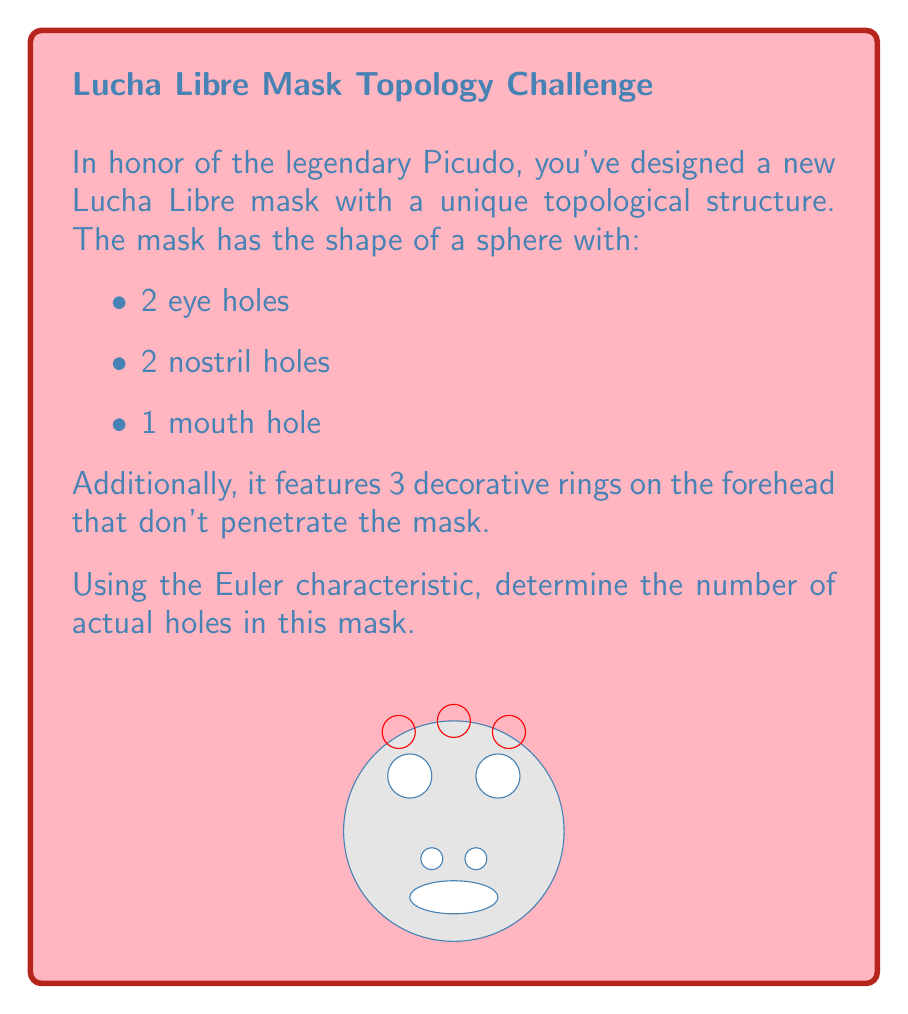Teach me how to tackle this problem. To solve this problem, we'll use the Euler characteristic formula for a sphere with holes:

$$\chi = 2 - 2g$$

Where $\chi$ is the Euler characteristic and $g$ is the genus (number of holes).

For a sphere, $\chi = 2$. Each hole reduces the Euler characteristic by 1.

Let's count the actual holes:
1. 2 eye holes
2. 2 nostril holes
3. 1 mouth hole

The decorative rings don't penetrate the mask, so they don't count as holes.

Total number of holes = 2 + 2 + 1 = 5

Now, we can set up the equation:

$$2 - 5 = 2 - 2g$$

Solving for $g$:

$$-3 = -2g$$
$$g = \frac{3}{2}$$

Since $g$ represents the number of holes and must be an integer in this context, we confirm that:

$$g = 5$$

This matches our initial count of 5 actual holes in the mask.
Answer: 5 holes 